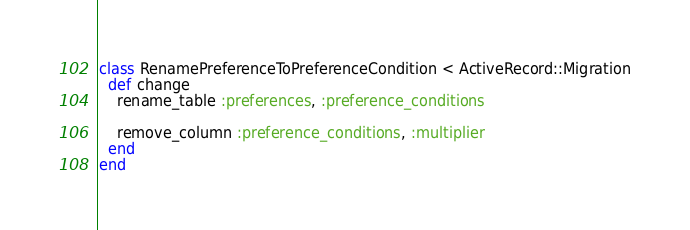Convert code to text. <code><loc_0><loc_0><loc_500><loc_500><_Ruby_>class RenamePreferenceToPreferenceCondition < ActiveRecord::Migration
  def change
    rename_table :preferences, :preference_conditions

    remove_column :preference_conditions, :multiplier
  end
end
</code> 